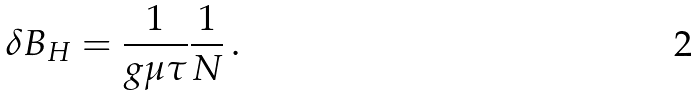<formula> <loc_0><loc_0><loc_500><loc_500>\delta B _ { H } = \frac { 1 } { g \mu \tau } \frac { 1 } { N } \, .</formula> 